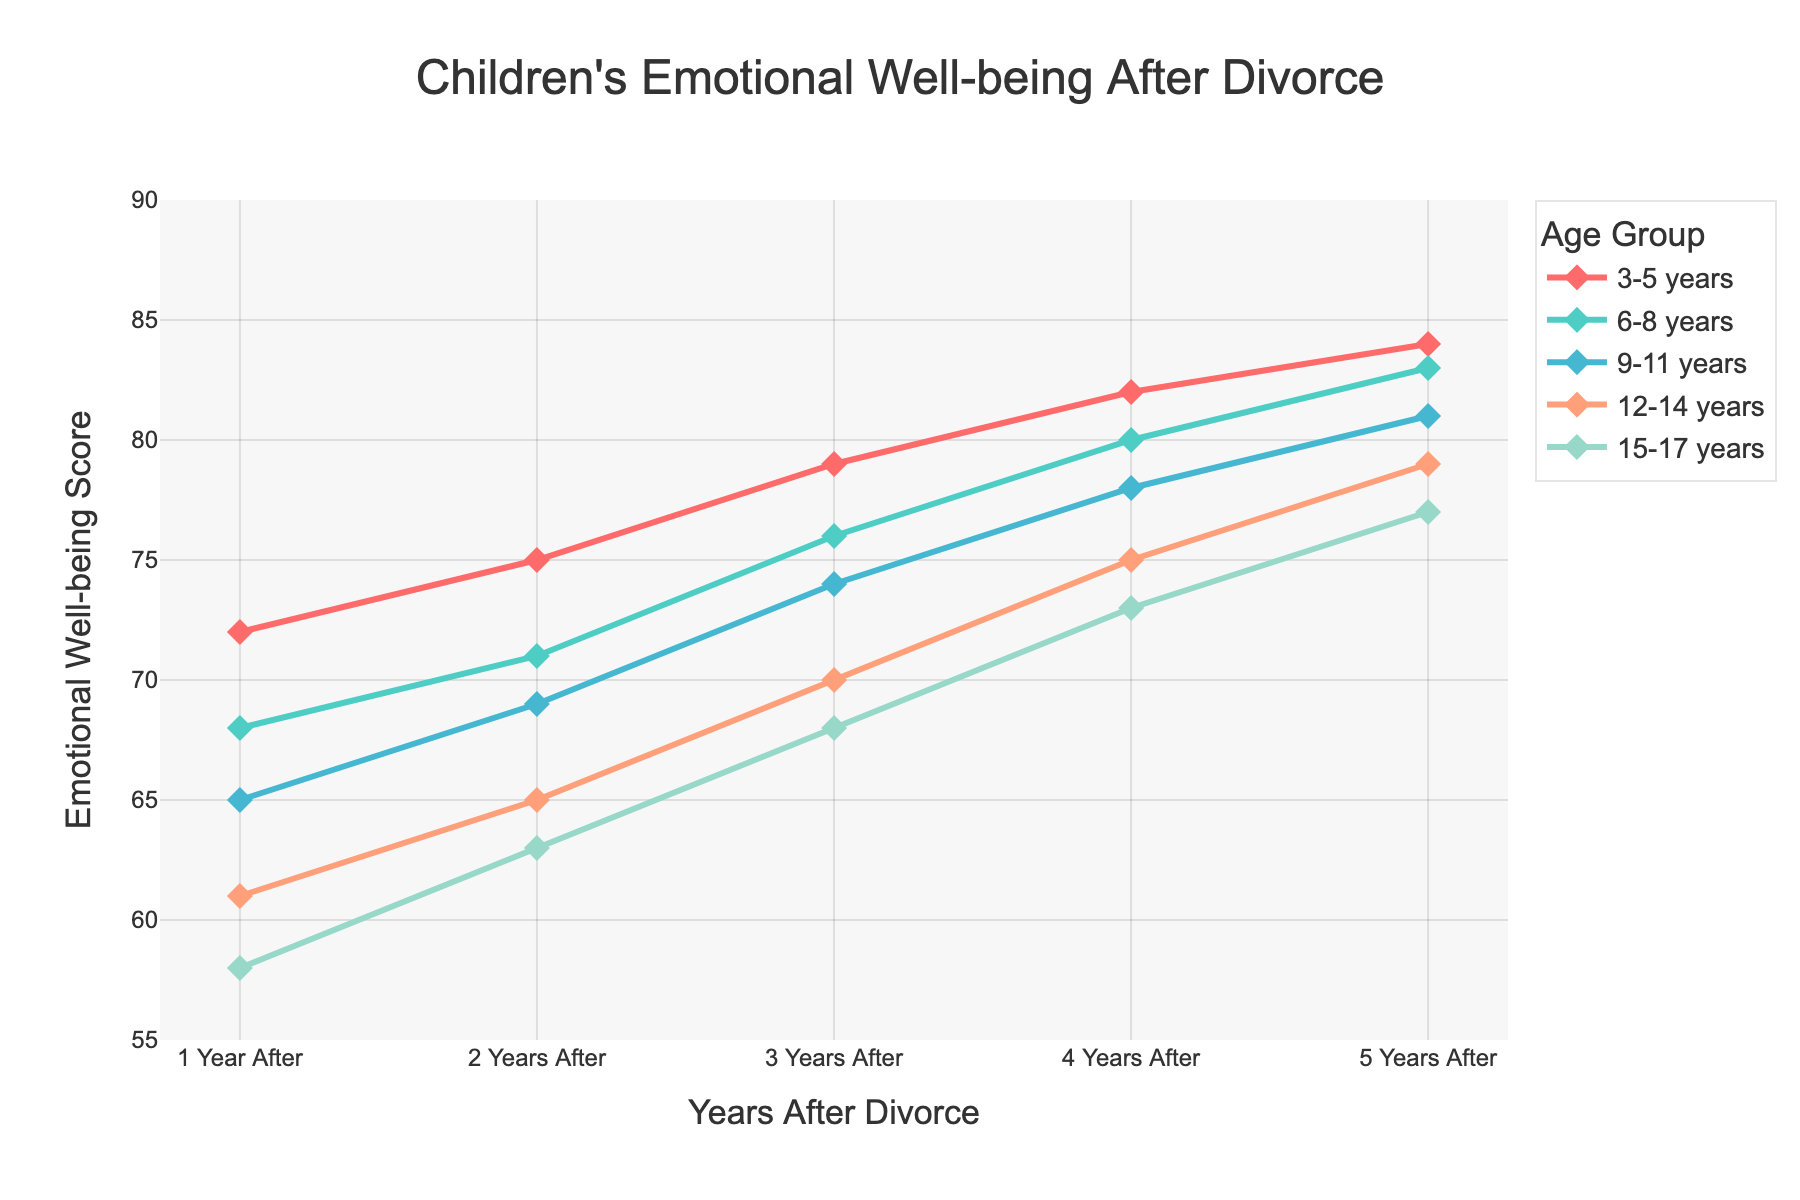What is the emotional well-being score for the 6-8 years age group 3 years after the divorce? To find the emotional well-being score for the 6-8 years age group 3 years after the divorce, locate the line representing the 6-8 years age group and then identify the score at the point labeled "3 Years After."
Answer: 76 Which age group has the highest emotional well-being score 5 years after the divorce? To determine which age group has the highest score 5 years after the divorce, compare the data points of all age groups at the "5 Years After" mark and identify the one with the highest value.
Answer: 3-5 years How does the emotional well-being score of the 9-11 years age group change from 1 year after to 5 years after the divorce? To calculate the change, find the score for the 9-11 years age group at both "1 Year After" and "5 Years After." Then, subtract the former from the latter (81 - 65).
Answer: Increase by 16 What is the average emotional well-being score for the 12-14 years age group across all years shown? First, add up the scores for the 12-14 years age group over all years (61 + 65 + 70 + 75 + 79 = 350). Then, divide by the number of years (5).
Answer: 70 Between which two consecutive years does the 15-17 years age group see the greatest increase in emotional well-being score? Calculate the increase between each pair of consecutive years for the 15-17 years age group: (63 - 58 = 5), (68 - 63 = 5), (73 - 68 = 5), and (77 - 73 = 4). The highest increase occurs between "1 Year After" and "2 Years After," "2 Years After" and "3 Years After," or "3 Years After" and "4 Years After" since they all have the same increase.
Answer: Various years with the same increase: 1-2, 2-3, 3-4 Which age group shows the lowest initial emotional well-being score 1 year after the divorce? To find the lowest initial score, examine the data points for all age groups at the "1 Year After" mark and identify the lowest value.
Answer: 15-17 years What is the combined emotional well-being score for the 3-5 years and the 12-14 years age groups 4 years after the divorce? Add the emotional well-being scores for the 3-5 years (82) and 12-14 years (75) age groups at the "4 Years After" mark. (82 + 75 = 157)
Answer: 157 Does any age group have a consistently increasing emotional well-being score each subsequent year? To determine if any age group has a consistently increasing score, check if the scores for each age group increase year over year without any decline.
Answer: Yes, all age groups 